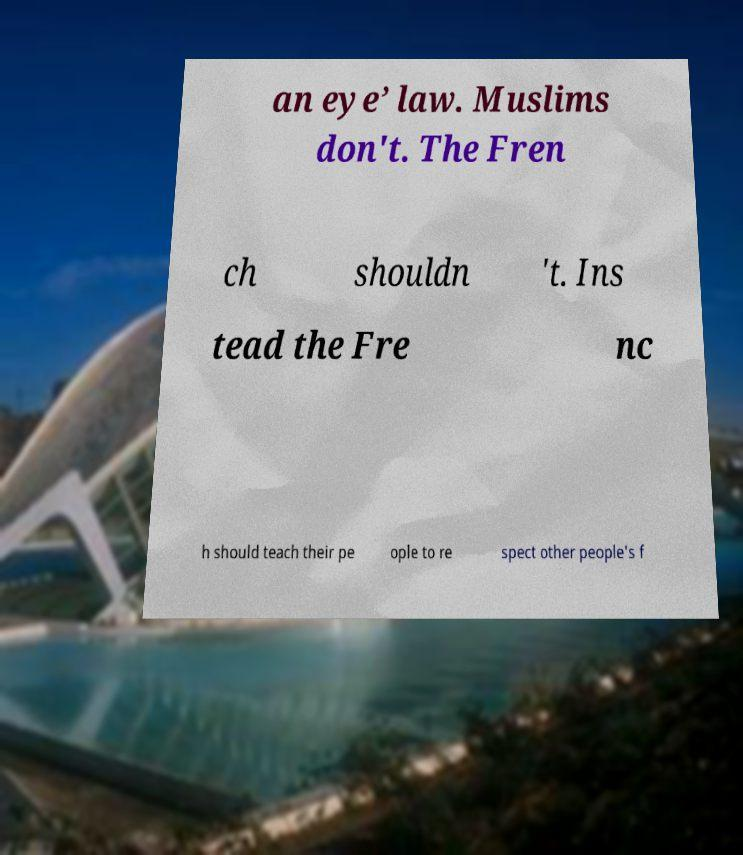For documentation purposes, I need the text within this image transcribed. Could you provide that? an eye’ law. Muslims don't. The Fren ch shouldn 't. Ins tead the Fre nc h should teach their pe ople to re spect other people's f 